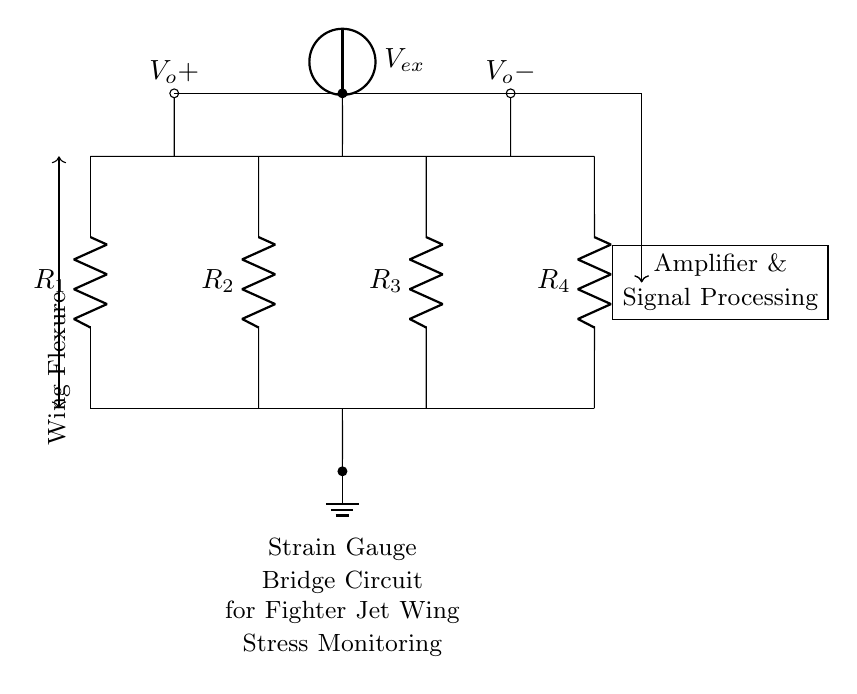What is the type of circuit shown in the diagram? The circuit is a strain gauge bridge circuit, which consists of resistors configured to measure changes in resistance due to strain on the structure.
Answer: strain gauge bridge How many resistors are present in the circuit? There are four resistors labeled R1, R2, R3, and R4, which are part of the bridge configuration for measuring strain.
Answer: four What is the purpose of the voltage source labeled V_ex? V_ex provides the excitation voltage necessary for the strain gauge bridge to operate, enabling it to sense changes in resistance that reflect structural stress.
Answer: excitation voltage Where are the output voltage nodes located? The output voltage nodes are located at points labeled V_o+ and V_o-, which measure the differential voltage from the bridge circuit.
Answer: V_o+ and V_o- What does the arrow indicating "Wing Flexure" suggest about the circuit? The arrow indicates the direction of wing flexure, illustrating how the strain gauge bridge is positioned to monitor structural changes due to stress on the fighter jet wing.
Answer: wing stress direction What follows the output nodes in the diagram? The diagram shows that the output nodes connect to an amplifier and signal processing unit, which further process the measured differential voltage for analysis.
Answer: amplifier and signal processing 